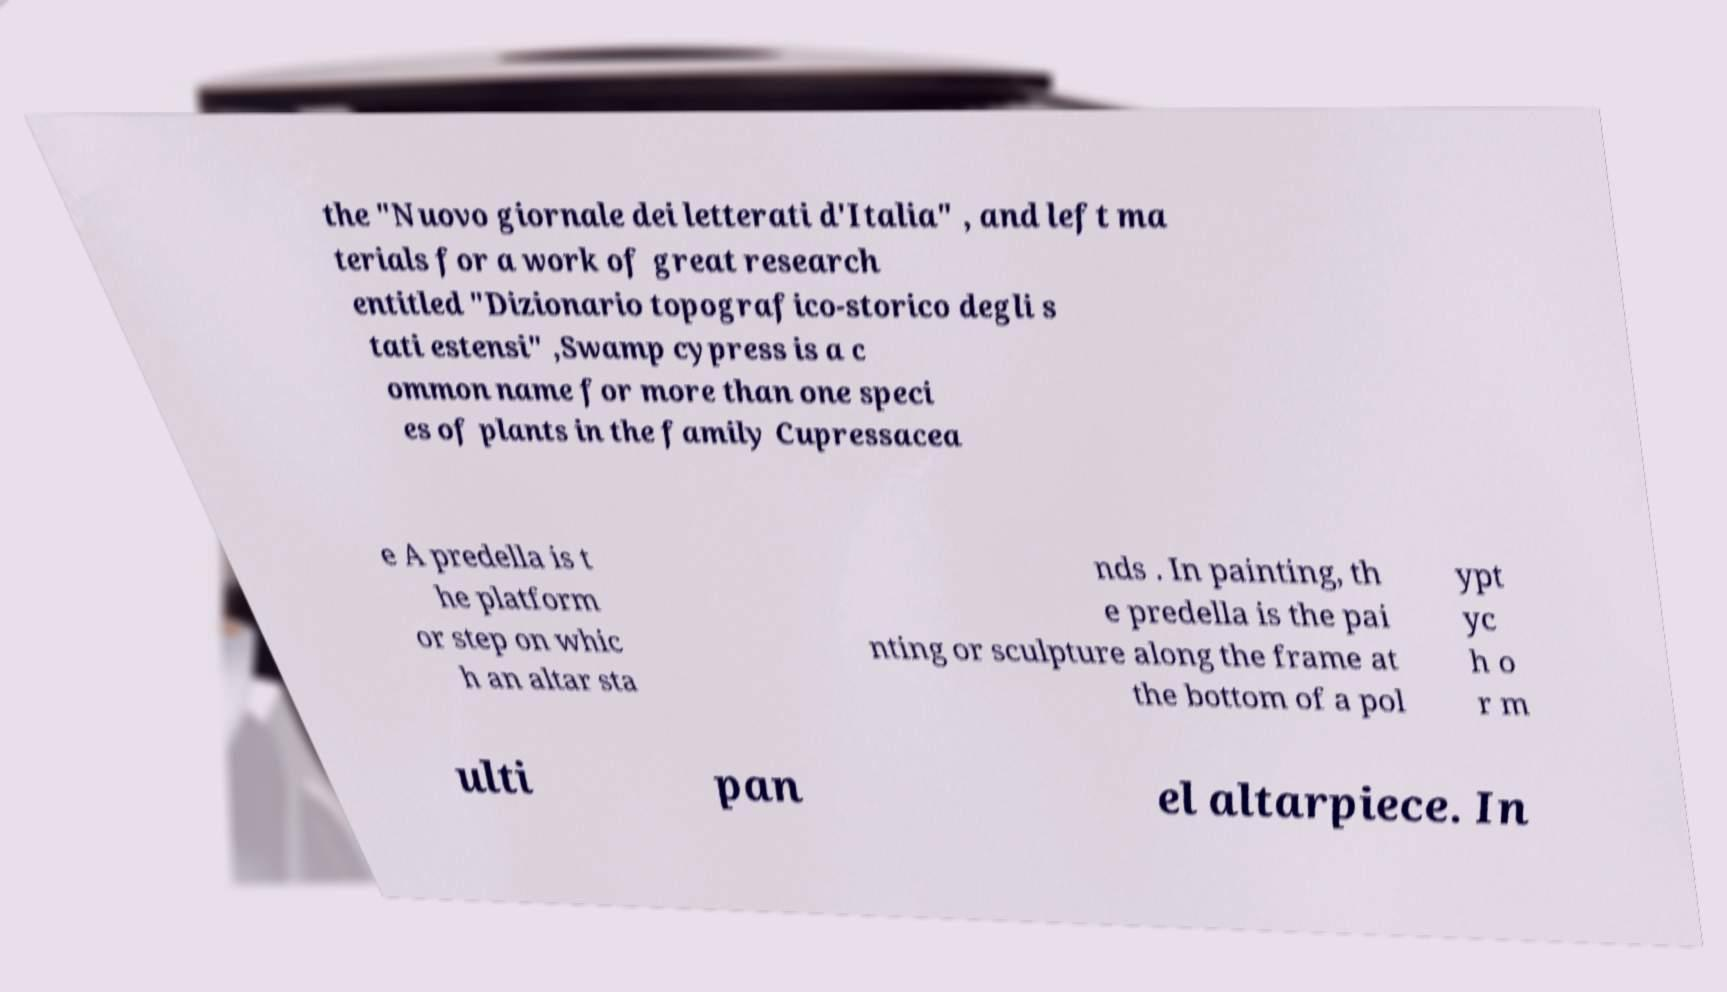What messages or text are displayed in this image? I need them in a readable, typed format. the "Nuovo giornale dei letterati d'Italia" , and left ma terials for a work of great research entitled "Dizionario topografico-storico degli s tati estensi" ,Swamp cypress is a c ommon name for more than one speci es of plants in the family Cupressacea e A predella is t he platform or step on whic h an altar sta nds . In painting, th e predella is the pai nting or sculpture along the frame at the bottom of a pol ypt yc h o r m ulti pan el altarpiece. In 